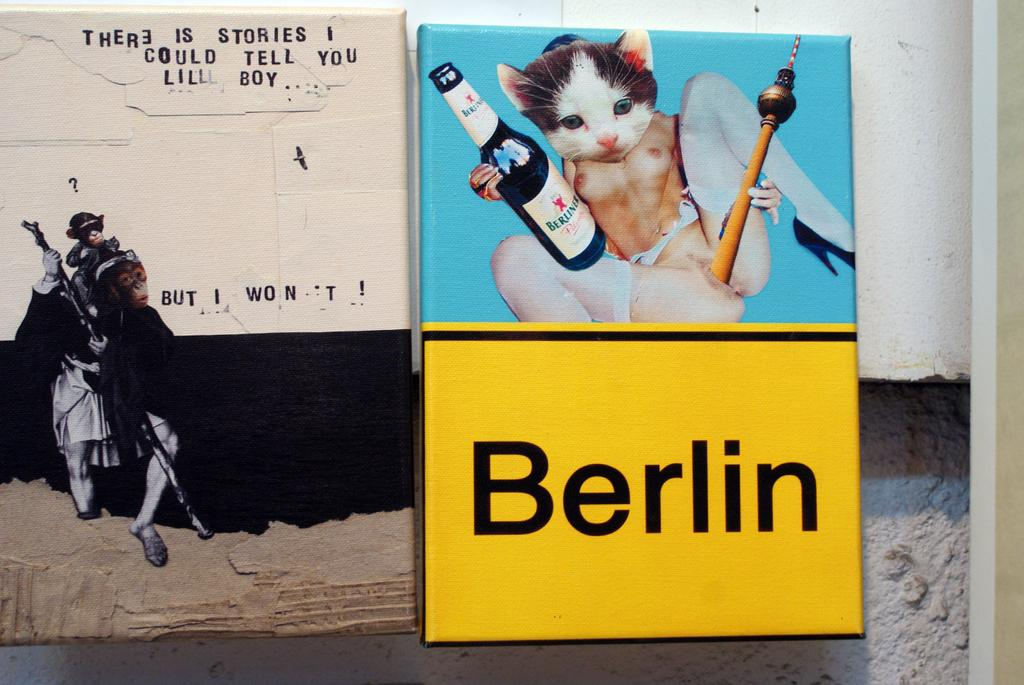What is depicted on the wall in the image? There is a painting on the wall in the image. What else can be seen on the wall besides the painting? There is text on the wall. What other object with an image can be seen in the image? There is a banner with an image in the image. What is written on the banner? There is text on the banner. How much debt is represented by the painting on the wall? The painting on the wall does not represent any debt; it is a visual representation in the form of an image. What type of brush is used to create the painting on the wall? There is no information about the type of brush used to create the painting on the wall, as the focus is on the image itself and not the process of creating it. 